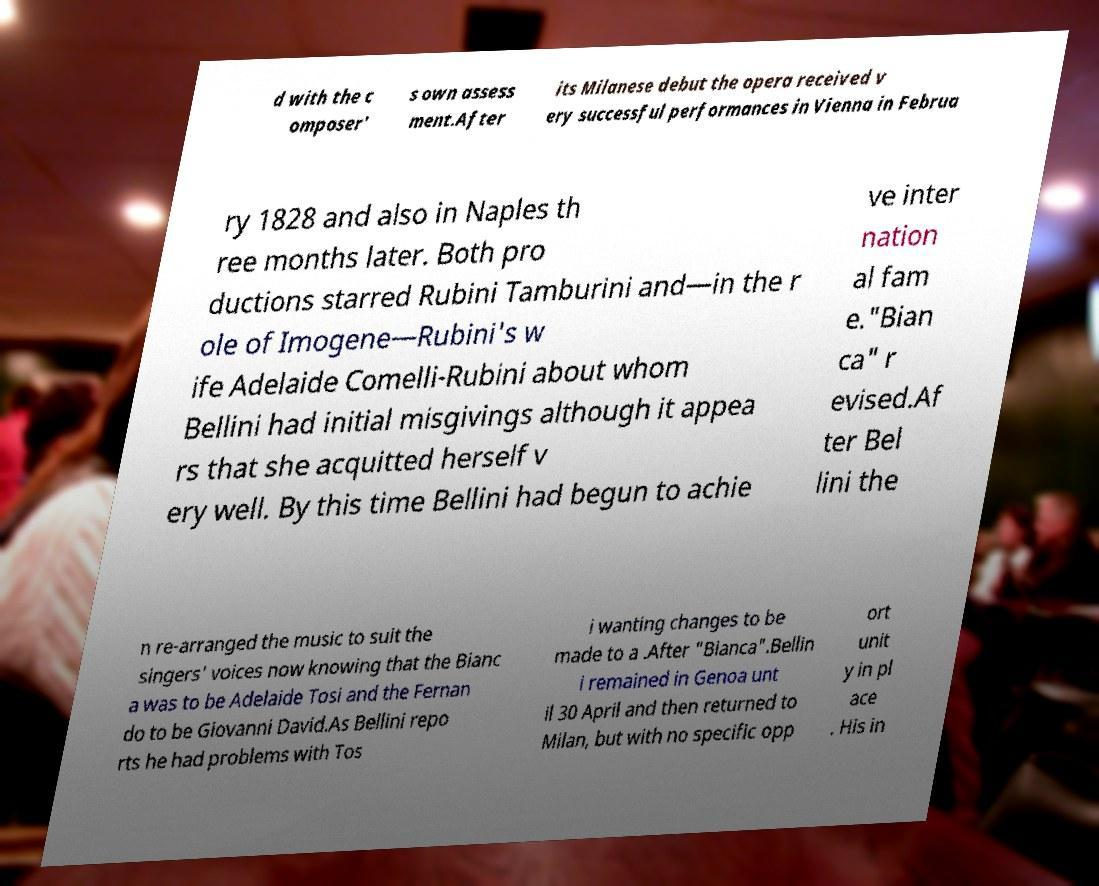Can you read and provide the text displayed in the image?This photo seems to have some interesting text. Can you extract and type it out for me? d with the c omposer' s own assess ment.After its Milanese debut the opera received v ery successful performances in Vienna in Februa ry 1828 and also in Naples th ree months later. Both pro ductions starred Rubini Tamburini and—in the r ole of Imogene—Rubini's w ife Adelaide Comelli-Rubini about whom Bellini had initial misgivings although it appea rs that she acquitted herself v ery well. By this time Bellini had begun to achie ve inter nation al fam e."Bian ca" r evised.Af ter Bel lini the n re-arranged the music to suit the singers' voices now knowing that the Bianc a was to be Adelaide Tosi and the Fernan do to be Giovanni David.As Bellini repo rts he had problems with Tos i wanting changes to be made to a .After "Bianca".Bellin i remained in Genoa unt il 30 April and then returned to Milan, but with no specific opp ort unit y in pl ace . His in 